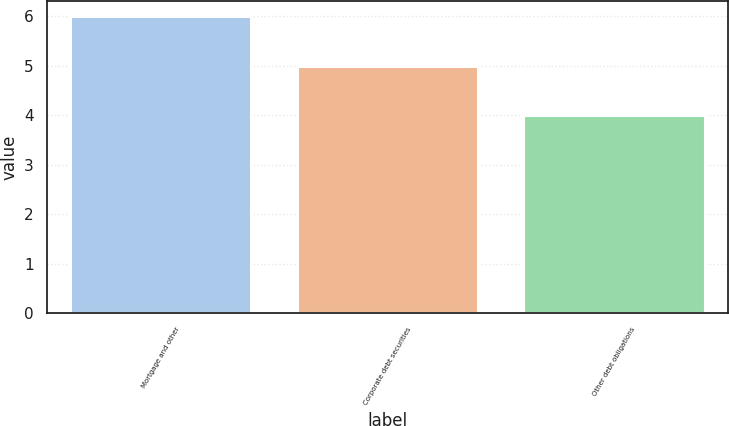<chart> <loc_0><loc_0><loc_500><loc_500><bar_chart><fcel>Mortgage and other<fcel>Corporate debt securities<fcel>Other debt obligations<nl><fcel>6<fcel>5<fcel>4<nl></chart> 